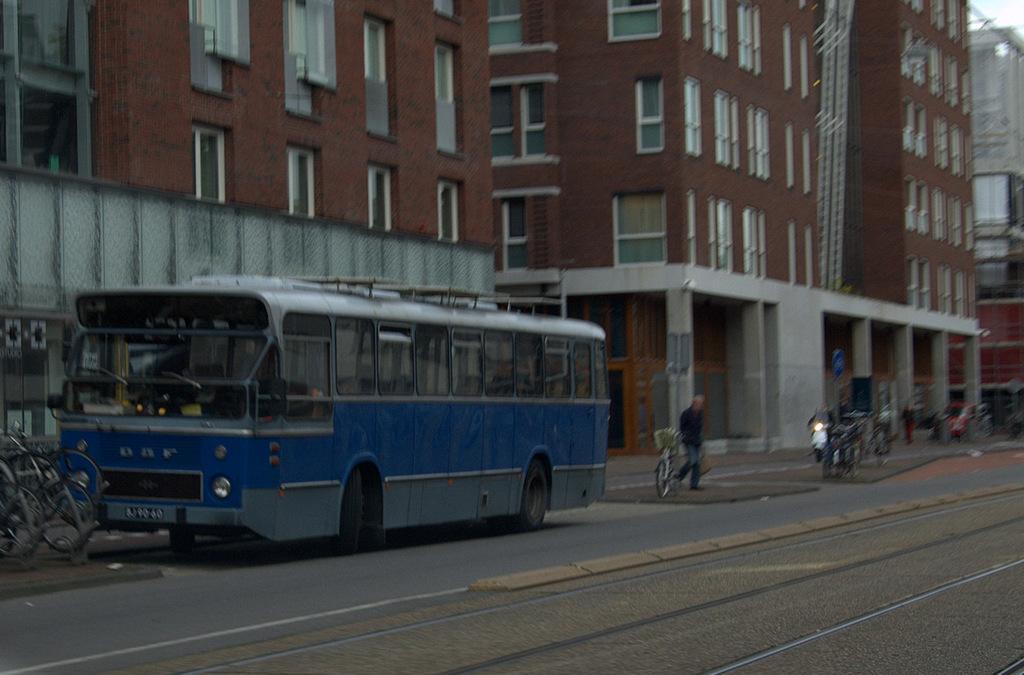Could you give a brief overview of what you see in this image? In the foreground of this picture, there is a track on the road and beside it there are vehicles on the road. In the background, there are buildings and the sky. 